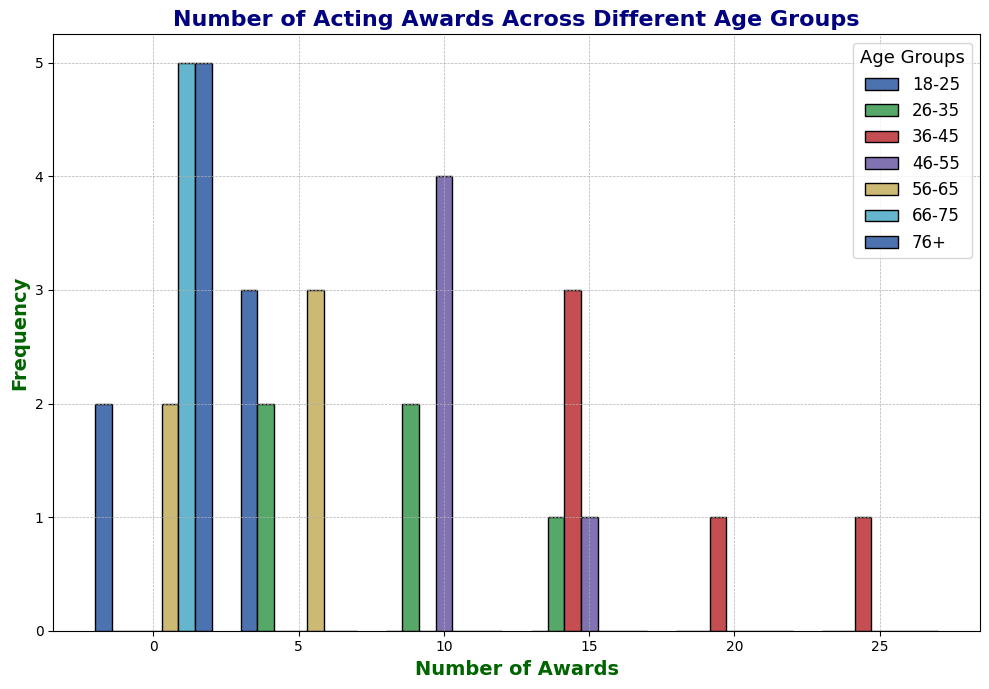What's the most frequent number of awards among actors aged 26-35? Look at the histogram bar height for the age group 26-35, which shows the frequency of different award counts. The highest bar for 26-35 marks the most frequent awards count.
Answer: 8 Which age group has the highest variability in the number of awards won? Variability can be assessed by the spread of the histogram bars for each age group. The 36-45 age group has bars that spread out more widely along the x-axis, indicating higher variability.
Answer: 36-45 What's the average number of awards for actors aged 46-55? The histogram shows the number of awards for the 46-55 age group. Sum the awards (16 + 12 + 14 + 10 + 11 = 63) and divide by the number of points (5).
Answer: 12.6 Compare the number of awards won by the youngest (18-25) and oldest (76+) age groups. Who wins more on average? Calculate the average awards in both groups. For 18-25: (5 + 8 + 2 + 3 + 7) / 5 = 5. For 76+: (1 + 0 + 1 + 2 + 0) / 5 = 0.8. Compare the two averages.
Answer: 18-25 Which age group has the highest number of cumulative awards? Calculate the total number of awards per age group by summing the histogram frequencies. The 36-45 age group has the highest total (22 + 18 + 19 + 25 + 17 = 101).
Answer: 36-45 Are there any age groups where no one has won more than 15 awards? Examine each age group's histogram bars. Only the 76+ age group has no bars extending past 15 awards.
Answer: 76+ What's the median number of awards for actors aged 56-65? The median is the middle value when sorted. The 56-65 awards are (3, 4, 5, 6, 7). The middle value is 5.
Answer: 5 Which age group features the tallest single bar, indicating the highest frequency for a particular award count? Identify the tallest histogram bar across age groups. The 36-45 age group has the tallest bar at the 25 awards mark.
Answer: 36-45 Between which two adjacent age groups is the change in the number of awards most noticeable? Compare the differences between adjacent age groups’ total awards visually. The biggest variation is noticed between 46-55 (63 awards) and 56-65 (25 awards).
Answer: 46-55 and 56-65 What's the range of awards (difference between maximum and minimum) for the age group 18-25? The range is the highest value minus the lowest value. The awards for 18-25 range from 2 to 8. Thus, 8 - 2 = 6.
Answer: 6 